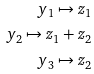<formula> <loc_0><loc_0><loc_500><loc_500>y _ { 1 } \mapsto z _ { 1 } \\ y _ { 2 } \mapsto z _ { 1 } + z _ { 2 } \\ y _ { 3 } \mapsto z _ { 2 }</formula> 